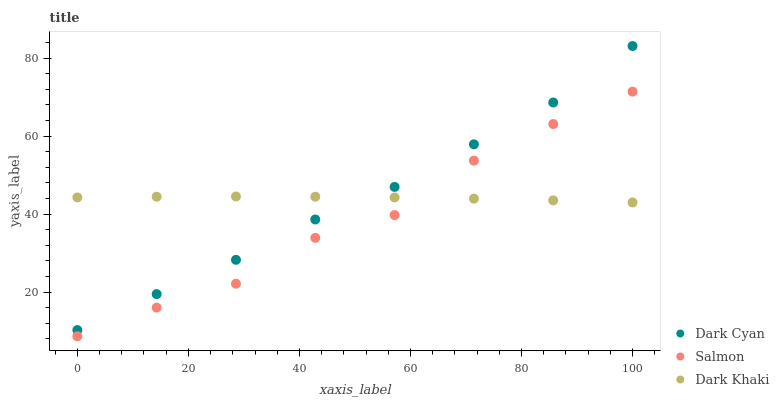Does Salmon have the minimum area under the curve?
Answer yes or no. Yes. Does Dark Khaki have the maximum area under the curve?
Answer yes or no. Yes. Does Dark Khaki have the minimum area under the curve?
Answer yes or no. No. Does Salmon have the maximum area under the curve?
Answer yes or no. No. Is Dark Khaki the smoothest?
Answer yes or no. Yes. Is Salmon the roughest?
Answer yes or no. Yes. Is Salmon the smoothest?
Answer yes or no. No. Is Dark Khaki the roughest?
Answer yes or no. No. Does Salmon have the lowest value?
Answer yes or no. Yes. Does Dark Khaki have the lowest value?
Answer yes or no. No. Does Dark Cyan have the highest value?
Answer yes or no. Yes. Does Salmon have the highest value?
Answer yes or no. No. Is Salmon less than Dark Cyan?
Answer yes or no. Yes. Is Dark Cyan greater than Salmon?
Answer yes or no. Yes. Does Dark Khaki intersect Dark Cyan?
Answer yes or no. Yes. Is Dark Khaki less than Dark Cyan?
Answer yes or no. No. Is Dark Khaki greater than Dark Cyan?
Answer yes or no. No. Does Salmon intersect Dark Cyan?
Answer yes or no. No. 